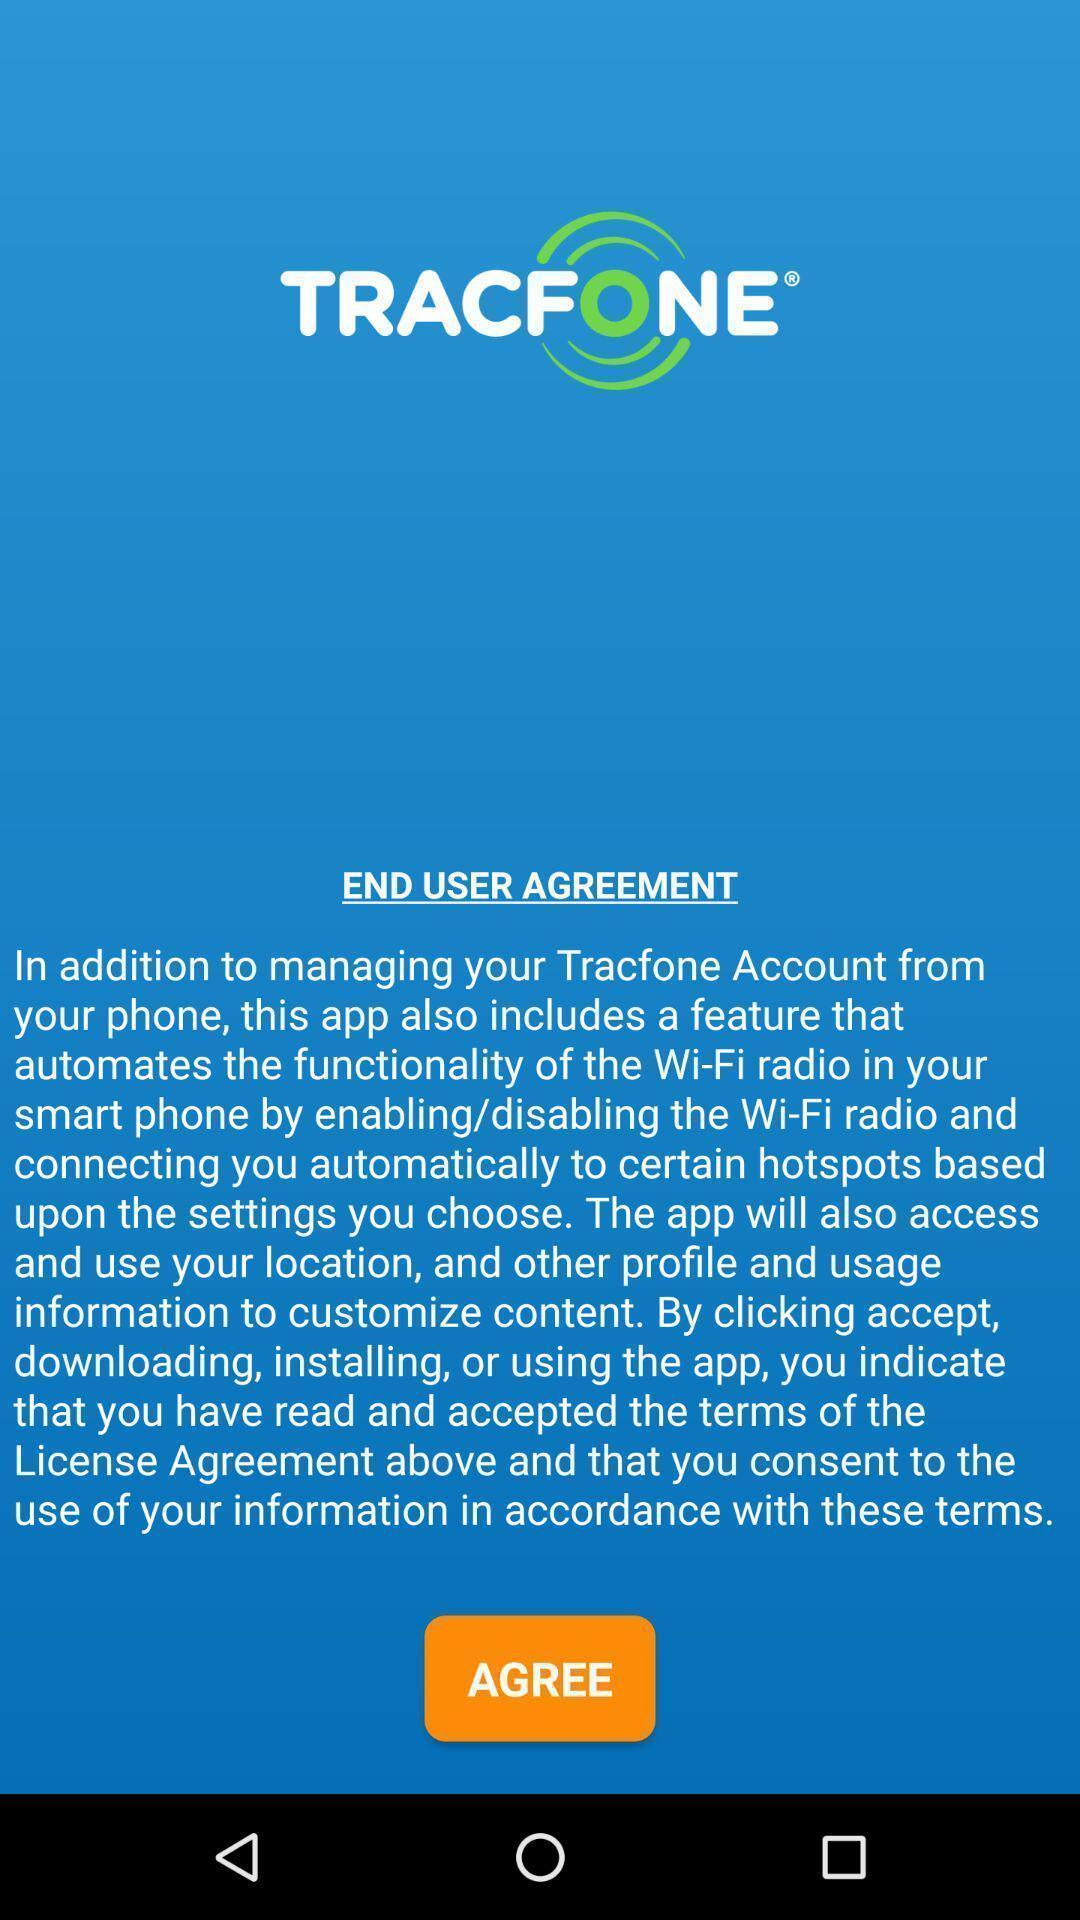Describe this image in words. Page showing no-contract mobile phone app. 